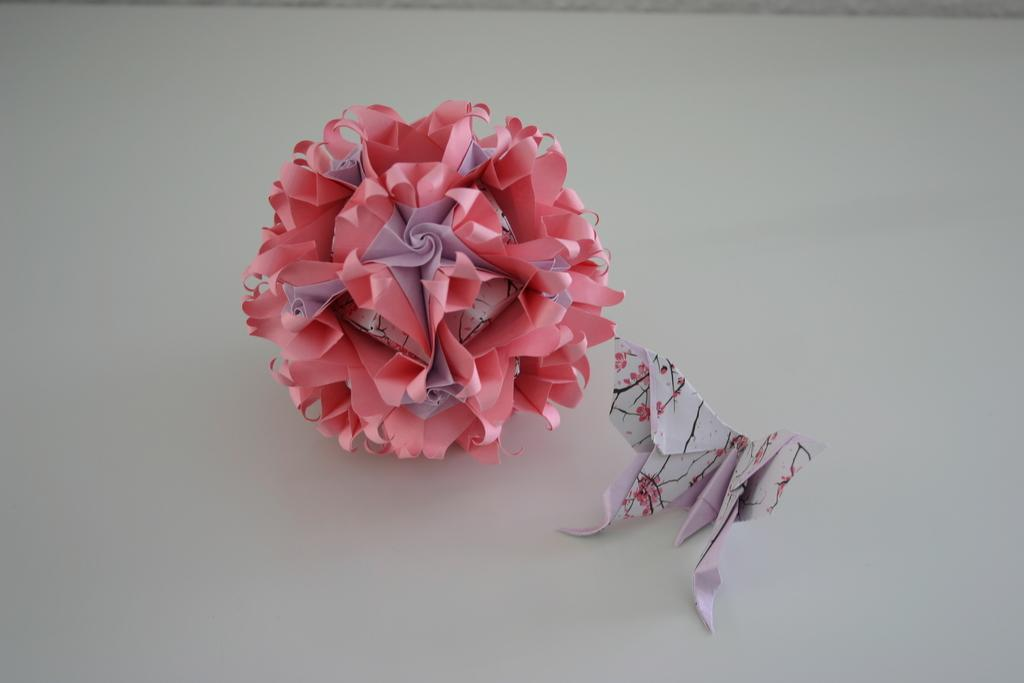What type of object is present in the image? There is a designed paper flower and a paper butterfly in the image. Where are these objects located? Both objects are on a table. What type of beam can be seen supporting the paper butterfly in the image? There is no beam present in the image; the paper butterfly is on a table along with the designed paper flower. 